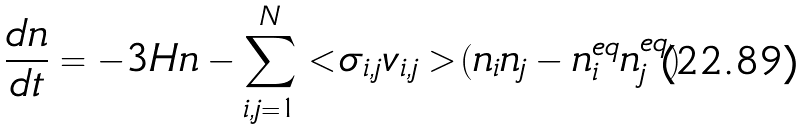<formula> <loc_0><loc_0><loc_500><loc_500>\frac { d n } { d t } = - 3 H n - \sum _ { i , j = 1 } ^ { N } < \sigma _ { i , j } v _ { i , j } > ( n _ { i } n _ { j } - n _ { i } ^ { e q } n _ { j } ^ { e q } )</formula> 